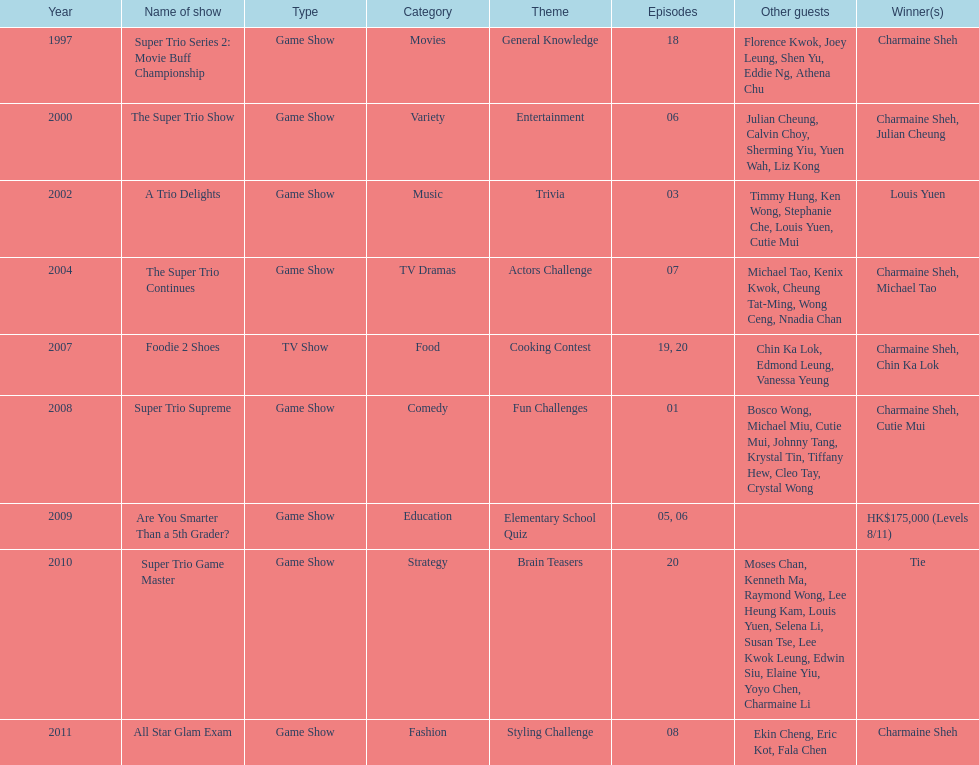I'm looking to parse the entire table for insights. Could you assist me with that? {'header': ['Year', 'Name of show', 'Type', 'Category', 'Theme', 'Episodes', 'Other guests', 'Winner(s)'], 'rows': [['1997', 'Super Trio Series 2: Movie Buff Championship', 'Game Show', 'Movies', 'General Knowledge', '18', 'Florence Kwok, Joey Leung, Shen Yu, Eddie Ng, Athena Chu', 'Charmaine Sheh'], ['2000', 'The Super Trio Show', 'Game Show', 'Variety', 'Entertainment', '06', 'Julian Cheung, Calvin Choy, Sherming Yiu, Yuen Wah, Liz Kong', 'Charmaine Sheh, Julian Cheung'], ['2002', 'A Trio Delights', 'Game Show', 'Music', 'Trivia', '03', 'Timmy Hung, Ken Wong, Stephanie Che, Louis Yuen, Cutie Mui', 'Louis Yuen'], ['2004', 'The Super Trio Continues', 'Game Show', 'TV Dramas', 'Actors Challenge', '07', 'Michael Tao, Kenix Kwok, Cheung Tat-Ming, Wong Ceng, Nnadia Chan', 'Charmaine Sheh, Michael Tao'], ['2007', 'Foodie 2 Shoes', 'TV Show', 'Food', 'Cooking Contest', '19, 20', 'Chin Ka Lok, Edmond Leung, Vanessa Yeung', 'Charmaine Sheh, Chin Ka Lok'], ['2008', 'Super Trio Supreme', 'Game Show', 'Comedy', 'Fun Challenges', '01', 'Bosco Wong, Michael Miu, Cutie Mui, Johnny Tang, Krystal Tin, Tiffany Hew, Cleo Tay, Crystal Wong', 'Charmaine Sheh, Cutie Mui'], ['2009', 'Are You Smarter Than a 5th Grader?', 'Game Show', 'Education', 'Elementary School Quiz', '05, 06', '', 'HK$175,000 (Levels 8/11)'], ['2010', 'Super Trio Game Master', 'Game Show', 'Strategy', 'Brain Teasers', '20', 'Moses Chan, Kenneth Ma, Raymond Wong, Lee Heung Kam, Louis Yuen, Selena Li, Susan Tse, Lee Kwok Leung, Edwin Siu, Elaine Yiu, Yoyo Chen, Charmaine Li', 'Tie'], ['2011', 'All Star Glam Exam', 'Game Show', 'Fashion', 'Styling Challenge', '08', 'Ekin Cheng, Eric Kot, Fala Chen', 'Charmaine Sheh']]} How many of shows had at least 5 episodes? 7. 